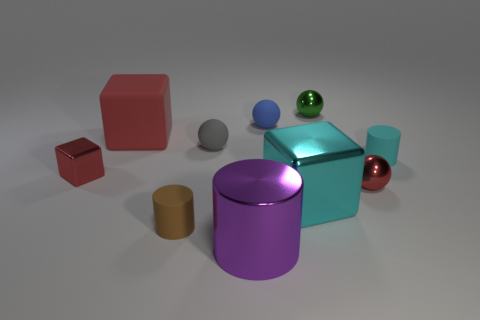Is the tiny metallic cube the same color as the large matte thing?
Offer a very short reply. Yes. There is a ball that is the same color as the tiny metal block; what size is it?
Offer a terse response. Small. What is the color of the small metallic ball in front of the large red cube?
Your response must be concise. Red. Does the blue rubber sphere have the same size as the cyan cylinder?
Offer a very short reply. Yes. There is a cube in front of the tiny metallic object left of the big red thing; what is its material?
Provide a succinct answer. Metal. How many spheres are the same color as the small block?
Your response must be concise. 1. Are there fewer big cyan objects that are in front of the big purple metal thing than big brown metallic cylinders?
Your answer should be very brief. No. What is the color of the small shiny ball that is behind the small cylinder to the right of the blue sphere?
Keep it short and to the point. Green. There is a metallic object in front of the big metallic block that is right of the red block in front of the small gray thing; how big is it?
Your answer should be very brief. Large. Are there fewer tiny gray rubber spheres in front of the brown matte cylinder than metallic balls on the right side of the tiny red ball?
Offer a terse response. No. 